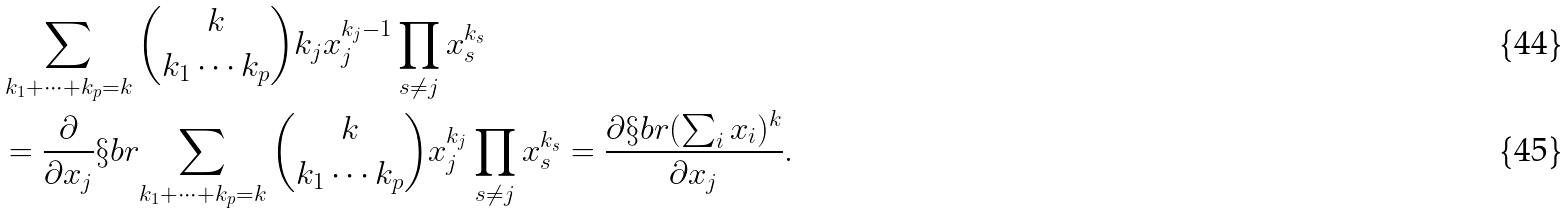Convert formula to latex. <formula><loc_0><loc_0><loc_500><loc_500>& \sum _ { k _ { 1 } + \cdots + k _ { p } = k } \binom { k } { k _ { 1 } \cdots k _ { p } } k _ { j } x _ { j } ^ { k _ { j } - 1 } \prod _ { s \not = j } x _ { s } ^ { k _ { s } } \\ & = \frac { \partial } { \partial x _ { j } } \S b r { \sum _ { k _ { 1 } + \cdots + k _ { p } = k } \binom { k } { k _ { 1 } \cdots k _ { p } } x _ { j } ^ { k _ { j } } \prod _ { s \not = j } x _ { s } ^ { k _ { s } } } = \frac { \partial \S b r { ( \sum _ { i } x _ { i } ) ^ { k } } } { \partial x _ { j } } .</formula> 